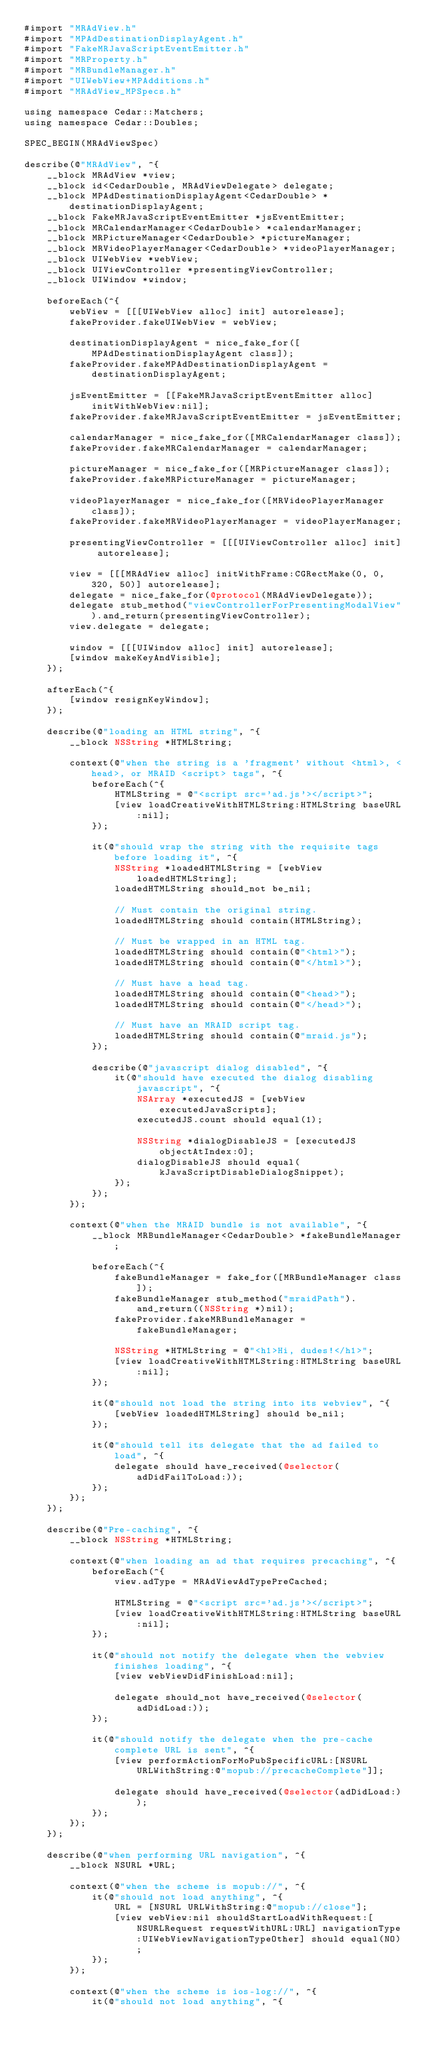Convert code to text. <code><loc_0><loc_0><loc_500><loc_500><_ObjectiveC_>#import "MRAdView.h"
#import "MPAdDestinationDisplayAgent.h"
#import "FakeMRJavaScriptEventEmitter.h"
#import "MRProperty.h"
#import "MRBundleManager.h"
#import "UIWebView+MPAdditions.h"
#import "MRAdView_MPSpecs.h"

using namespace Cedar::Matchers;
using namespace Cedar::Doubles;

SPEC_BEGIN(MRAdViewSpec)

describe(@"MRAdView", ^{
    __block MRAdView *view;
    __block id<CedarDouble, MRAdViewDelegate> delegate;
    __block MPAdDestinationDisplayAgent<CedarDouble> *destinationDisplayAgent;
    __block FakeMRJavaScriptEventEmitter *jsEventEmitter;
    __block MRCalendarManager<CedarDouble> *calendarManager;
    __block MRPictureManager<CedarDouble> *pictureManager;
    __block MRVideoPlayerManager<CedarDouble> *videoPlayerManager;
    __block UIWebView *webView;
    __block UIViewController *presentingViewController;
    __block UIWindow *window;

    beforeEach(^{
        webView = [[[UIWebView alloc] init] autorelease];
        fakeProvider.fakeUIWebView = webView;

        destinationDisplayAgent = nice_fake_for([MPAdDestinationDisplayAgent class]);
        fakeProvider.fakeMPAdDestinationDisplayAgent = destinationDisplayAgent;

        jsEventEmitter = [[FakeMRJavaScriptEventEmitter alloc] initWithWebView:nil];
        fakeProvider.fakeMRJavaScriptEventEmitter = jsEventEmitter;

        calendarManager = nice_fake_for([MRCalendarManager class]);
        fakeProvider.fakeMRCalendarManager = calendarManager;

        pictureManager = nice_fake_for([MRPictureManager class]);
        fakeProvider.fakeMRPictureManager = pictureManager;

        videoPlayerManager = nice_fake_for([MRVideoPlayerManager class]);
        fakeProvider.fakeMRVideoPlayerManager = videoPlayerManager;

        presentingViewController = [[[UIViewController alloc] init] autorelease];

        view = [[[MRAdView alloc] initWithFrame:CGRectMake(0, 0, 320, 50)] autorelease];
        delegate = nice_fake_for(@protocol(MRAdViewDelegate));
        delegate stub_method("viewControllerForPresentingModalView").and_return(presentingViewController);
        view.delegate = delegate;

        window = [[[UIWindow alloc] init] autorelease];
        [window makeKeyAndVisible];
    });

    afterEach(^{
        [window resignKeyWindow];
    });

    describe(@"loading an HTML string", ^{
        __block NSString *HTMLString;

        context(@"when the string is a 'fragment' without <html>, <head>, or MRAID <script> tags", ^{
            beforeEach(^{
                HTMLString = @"<script src='ad.js'></script>";
                [view loadCreativeWithHTMLString:HTMLString baseURL:nil];
            });

            it(@"should wrap the string with the requisite tags before loading it", ^{
                NSString *loadedHTMLString = [webView loadedHTMLString];
                loadedHTMLString should_not be_nil;

                // Must contain the original string.
                loadedHTMLString should contain(HTMLString);

                // Must be wrapped in an HTML tag.
                loadedHTMLString should contain(@"<html>");
                loadedHTMLString should contain(@"</html>");

                // Must have a head tag.
                loadedHTMLString should contain(@"<head>");
                loadedHTMLString should contain(@"</head>");

                // Must have an MRAID script tag.
                loadedHTMLString should contain(@"mraid.js");
            });

            describe(@"javascript dialog disabled", ^{
                it(@"should have executed the dialog disabling javascript", ^{
                    NSArray *executedJS = [webView executedJavaScripts];
                    executedJS.count should equal(1);

                    NSString *dialogDisableJS = [executedJS objectAtIndex:0];
                    dialogDisableJS should equal(kJavaScriptDisableDialogSnippet);
                });
            });
        });

        context(@"when the MRAID bundle is not available", ^{
            __block MRBundleManager<CedarDouble> *fakeBundleManager;

            beforeEach(^{
                fakeBundleManager = fake_for([MRBundleManager class]);
                fakeBundleManager stub_method("mraidPath").and_return((NSString *)nil);
                fakeProvider.fakeMRBundleManager = fakeBundleManager;

                NSString *HTMLString = @"<h1>Hi, dudes!</h1>";
                [view loadCreativeWithHTMLString:HTMLString baseURL:nil];
            });

            it(@"should not load the string into its webview", ^{
                [webView loadedHTMLString] should be_nil;
            });

            it(@"should tell its delegate that the ad failed to load", ^{
                delegate should have_received(@selector(adDidFailToLoad:));
            });
        });
    });

    describe(@"Pre-caching", ^{
        __block NSString *HTMLString;

        context(@"when loading an ad that requires precaching", ^{
            beforeEach(^{
                view.adType = MRAdViewAdTypePreCached;

                HTMLString = @"<script src='ad.js'></script>";
                [view loadCreativeWithHTMLString:HTMLString baseURL:nil];
            });

            it(@"should not notify the delegate when the webview finishes loading", ^{
                [view webViewDidFinishLoad:nil];

                delegate should_not have_received(@selector(adDidLoad:));
            });

            it(@"should notify the delegate when the pre-cache complete URL is sent", ^{
                [view performActionForMoPubSpecificURL:[NSURL URLWithString:@"mopub://precacheComplete"]];

                delegate should have_received(@selector(adDidLoad:));
            });
        });
    });

    describe(@"when performing URL navigation", ^{
        __block NSURL *URL;

        context(@"when the scheme is mopub://", ^{
            it(@"should not load anything", ^{
                URL = [NSURL URLWithString:@"mopub://close"];
                [view webView:nil shouldStartLoadWithRequest:[NSURLRequest requestWithURL:URL] navigationType:UIWebViewNavigationTypeOther] should equal(NO);
            });
        });

        context(@"when the scheme is ios-log://", ^{
            it(@"should not load anything", ^{</code> 